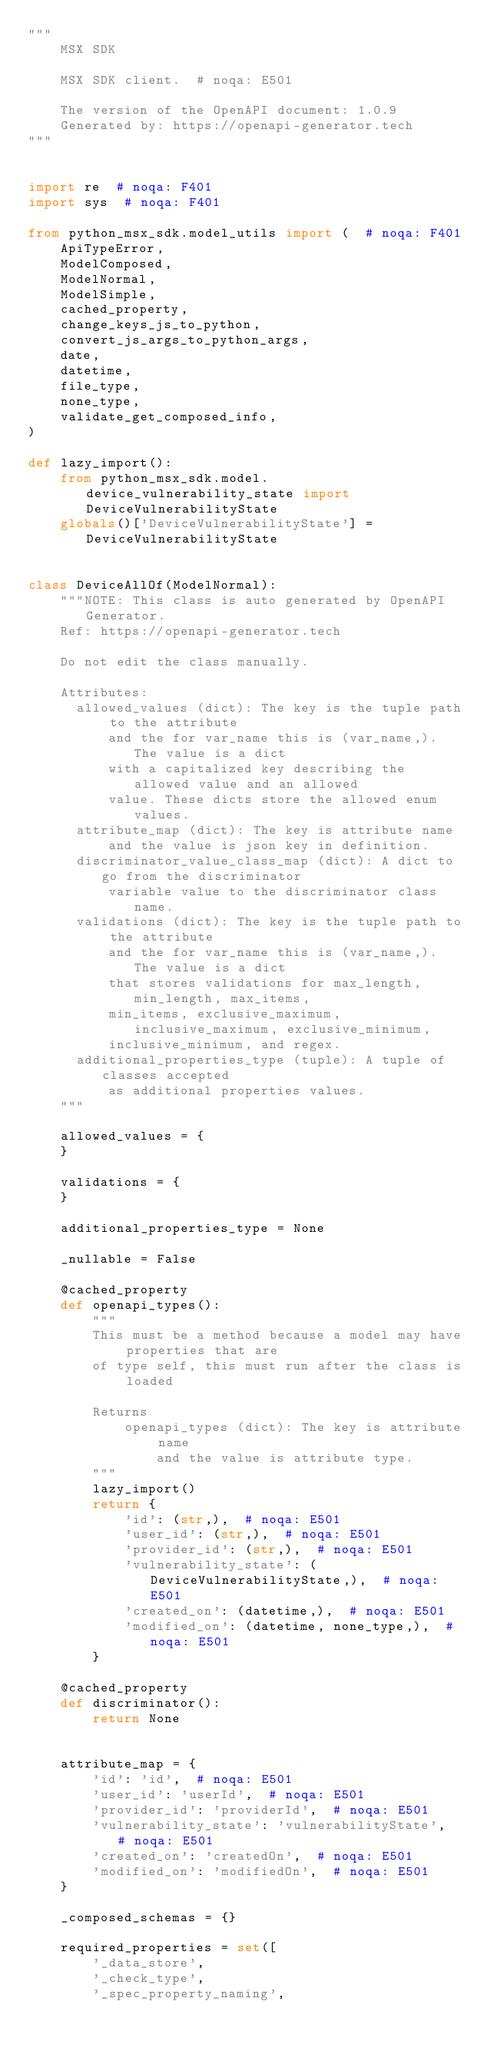Convert code to text. <code><loc_0><loc_0><loc_500><loc_500><_Python_>"""
    MSX SDK

    MSX SDK client.  # noqa: E501

    The version of the OpenAPI document: 1.0.9
    Generated by: https://openapi-generator.tech
"""


import re  # noqa: F401
import sys  # noqa: F401

from python_msx_sdk.model_utils import (  # noqa: F401
    ApiTypeError,
    ModelComposed,
    ModelNormal,
    ModelSimple,
    cached_property,
    change_keys_js_to_python,
    convert_js_args_to_python_args,
    date,
    datetime,
    file_type,
    none_type,
    validate_get_composed_info,
)

def lazy_import():
    from python_msx_sdk.model.device_vulnerability_state import DeviceVulnerabilityState
    globals()['DeviceVulnerabilityState'] = DeviceVulnerabilityState


class DeviceAllOf(ModelNormal):
    """NOTE: This class is auto generated by OpenAPI Generator.
    Ref: https://openapi-generator.tech

    Do not edit the class manually.

    Attributes:
      allowed_values (dict): The key is the tuple path to the attribute
          and the for var_name this is (var_name,). The value is a dict
          with a capitalized key describing the allowed value and an allowed
          value. These dicts store the allowed enum values.
      attribute_map (dict): The key is attribute name
          and the value is json key in definition.
      discriminator_value_class_map (dict): A dict to go from the discriminator
          variable value to the discriminator class name.
      validations (dict): The key is the tuple path to the attribute
          and the for var_name this is (var_name,). The value is a dict
          that stores validations for max_length, min_length, max_items,
          min_items, exclusive_maximum, inclusive_maximum, exclusive_minimum,
          inclusive_minimum, and regex.
      additional_properties_type (tuple): A tuple of classes accepted
          as additional properties values.
    """

    allowed_values = {
    }

    validations = {
    }

    additional_properties_type = None

    _nullable = False

    @cached_property
    def openapi_types():
        """
        This must be a method because a model may have properties that are
        of type self, this must run after the class is loaded

        Returns
            openapi_types (dict): The key is attribute name
                and the value is attribute type.
        """
        lazy_import()
        return {
            'id': (str,),  # noqa: E501
            'user_id': (str,),  # noqa: E501
            'provider_id': (str,),  # noqa: E501
            'vulnerability_state': (DeviceVulnerabilityState,),  # noqa: E501
            'created_on': (datetime,),  # noqa: E501
            'modified_on': (datetime, none_type,),  # noqa: E501
        }

    @cached_property
    def discriminator():
        return None


    attribute_map = {
        'id': 'id',  # noqa: E501
        'user_id': 'userId',  # noqa: E501
        'provider_id': 'providerId',  # noqa: E501
        'vulnerability_state': 'vulnerabilityState',  # noqa: E501
        'created_on': 'createdOn',  # noqa: E501
        'modified_on': 'modifiedOn',  # noqa: E501
    }

    _composed_schemas = {}

    required_properties = set([
        '_data_store',
        '_check_type',
        '_spec_property_naming',</code> 